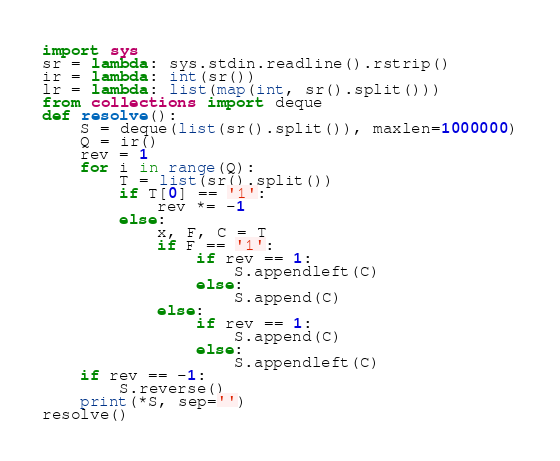Convert code to text. <code><loc_0><loc_0><loc_500><loc_500><_Python_>import sys
sr = lambda: sys.stdin.readline().rstrip()
ir = lambda: int(sr())
lr = lambda: list(map(int, sr().split()))
from collections import deque
def resolve():
    S = deque(list(sr().split()), maxlen=1000000)
    Q = ir()
    rev = 1
    for i in range(Q):
        T = list(sr().split())
        if T[0] == '1':
            rev *= -1
        else:
            x, F, C = T
            if F == '1':
                if rev == 1:
                    S.appendleft(C)
                else:
                    S.append(C)
            else:
                if rev == 1:
                    S.append(C)
                else:
                    S.appendleft(C)
    if rev == -1:
        S.reverse()
    print(*S, sep='')
resolve()</code> 